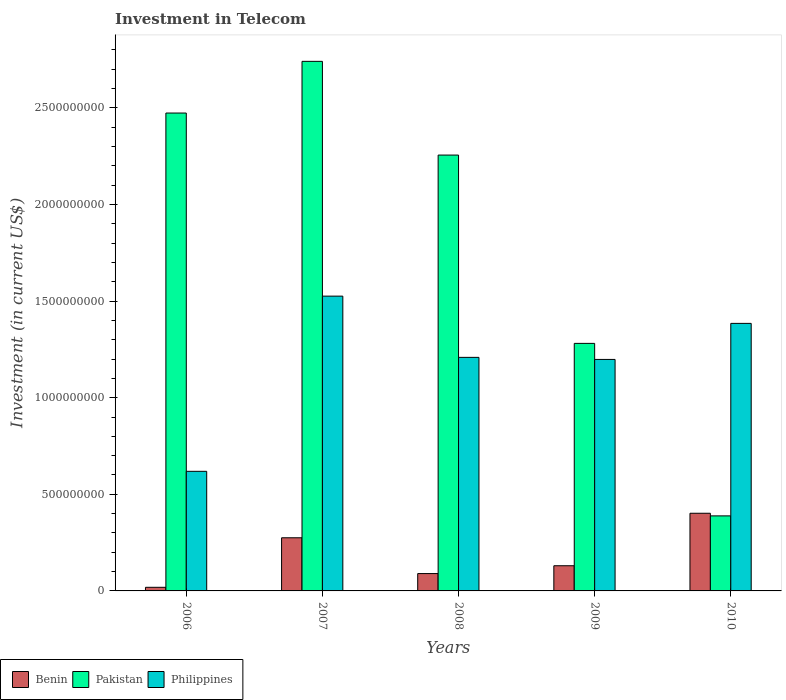How many different coloured bars are there?
Your answer should be compact. 3. Are the number of bars on each tick of the X-axis equal?
Provide a short and direct response. Yes. In how many cases, is the number of bars for a given year not equal to the number of legend labels?
Ensure brevity in your answer.  0. What is the amount invested in telecom in Pakistan in 2010?
Give a very brief answer. 3.88e+08. Across all years, what is the maximum amount invested in telecom in Pakistan?
Provide a succinct answer. 2.74e+09. Across all years, what is the minimum amount invested in telecom in Philippines?
Provide a short and direct response. 6.19e+08. In which year was the amount invested in telecom in Philippines maximum?
Your answer should be very brief. 2007. In which year was the amount invested in telecom in Pakistan minimum?
Provide a short and direct response. 2010. What is the total amount invested in telecom in Pakistan in the graph?
Provide a succinct answer. 9.14e+09. What is the difference between the amount invested in telecom in Pakistan in 2008 and that in 2009?
Make the answer very short. 9.74e+08. What is the difference between the amount invested in telecom in Philippines in 2009 and the amount invested in telecom in Pakistan in 2006?
Make the answer very short. -1.28e+09. What is the average amount invested in telecom in Philippines per year?
Give a very brief answer. 1.19e+09. In the year 2009, what is the difference between the amount invested in telecom in Pakistan and amount invested in telecom in Benin?
Your answer should be compact. 1.15e+09. What is the ratio of the amount invested in telecom in Benin in 2009 to that in 2010?
Make the answer very short. 0.32. What is the difference between the highest and the second highest amount invested in telecom in Pakistan?
Ensure brevity in your answer.  2.68e+08. What is the difference between the highest and the lowest amount invested in telecom in Philippines?
Offer a terse response. 9.07e+08. Is the sum of the amount invested in telecom in Pakistan in 2006 and 2007 greater than the maximum amount invested in telecom in Benin across all years?
Your response must be concise. Yes. What does the 1st bar from the left in 2010 represents?
Offer a terse response. Benin. What does the 1st bar from the right in 2009 represents?
Keep it short and to the point. Philippines. Is it the case that in every year, the sum of the amount invested in telecom in Benin and amount invested in telecom in Pakistan is greater than the amount invested in telecom in Philippines?
Your answer should be very brief. No. What is the difference between two consecutive major ticks on the Y-axis?
Your response must be concise. 5.00e+08. Are the values on the major ticks of Y-axis written in scientific E-notation?
Your answer should be compact. No. How are the legend labels stacked?
Provide a short and direct response. Horizontal. What is the title of the graph?
Your answer should be compact. Investment in Telecom. What is the label or title of the Y-axis?
Provide a succinct answer. Investment (in current US$). What is the Investment (in current US$) of Benin in 2006?
Keep it short and to the point. 1.87e+07. What is the Investment (in current US$) of Pakistan in 2006?
Offer a very short reply. 2.47e+09. What is the Investment (in current US$) of Philippines in 2006?
Give a very brief answer. 6.19e+08. What is the Investment (in current US$) in Benin in 2007?
Provide a succinct answer. 2.75e+08. What is the Investment (in current US$) in Pakistan in 2007?
Make the answer very short. 2.74e+09. What is the Investment (in current US$) of Philippines in 2007?
Provide a short and direct response. 1.53e+09. What is the Investment (in current US$) of Benin in 2008?
Your answer should be compact. 8.98e+07. What is the Investment (in current US$) in Pakistan in 2008?
Your response must be concise. 2.26e+09. What is the Investment (in current US$) in Philippines in 2008?
Ensure brevity in your answer.  1.21e+09. What is the Investment (in current US$) in Benin in 2009?
Your answer should be compact. 1.30e+08. What is the Investment (in current US$) of Pakistan in 2009?
Offer a terse response. 1.28e+09. What is the Investment (in current US$) in Philippines in 2009?
Provide a succinct answer. 1.20e+09. What is the Investment (in current US$) in Benin in 2010?
Your response must be concise. 4.02e+08. What is the Investment (in current US$) of Pakistan in 2010?
Give a very brief answer. 3.88e+08. What is the Investment (in current US$) in Philippines in 2010?
Your response must be concise. 1.38e+09. Across all years, what is the maximum Investment (in current US$) in Benin?
Offer a very short reply. 4.02e+08. Across all years, what is the maximum Investment (in current US$) in Pakistan?
Ensure brevity in your answer.  2.74e+09. Across all years, what is the maximum Investment (in current US$) in Philippines?
Your answer should be very brief. 1.53e+09. Across all years, what is the minimum Investment (in current US$) of Benin?
Give a very brief answer. 1.87e+07. Across all years, what is the minimum Investment (in current US$) in Pakistan?
Make the answer very short. 3.88e+08. Across all years, what is the minimum Investment (in current US$) of Philippines?
Your answer should be very brief. 6.19e+08. What is the total Investment (in current US$) in Benin in the graph?
Provide a short and direct response. 9.16e+08. What is the total Investment (in current US$) of Pakistan in the graph?
Ensure brevity in your answer.  9.14e+09. What is the total Investment (in current US$) in Philippines in the graph?
Offer a terse response. 5.94e+09. What is the difference between the Investment (in current US$) of Benin in 2006 and that in 2007?
Offer a very short reply. -2.56e+08. What is the difference between the Investment (in current US$) in Pakistan in 2006 and that in 2007?
Offer a terse response. -2.68e+08. What is the difference between the Investment (in current US$) in Philippines in 2006 and that in 2007?
Keep it short and to the point. -9.07e+08. What is the difference between the Investment (in current US$) of Benin in 2006 and that in 2008?
Ensure brevity in your answer.  -7.11e+07. What is the difference between the Investment (in current US$) of Pakistan in 2006 and that in 2008?
Provide a short and direct response. 2.18e+08. What is the difference between the Investment (in current US$) of Philippines in 2006 and that in 2008?
Your answer should be very brief. -5.90e+08. What is the difference between the Investment (in current US$) in Benin in 2006 and that in 2009?
Your response must be concise. -1.12e+08. What is the difference between the Investment (in current US$) of Pakistan in 2006 and that in 2009?
Offer a very short reply. 1.19e+09. What is the difference between the Investment (in current US$) of Philippines in 2006 and that in 2009?
Keep it short and to the point. -5.79e+08. What is the difference between the Investment (in current US$) of Benin in 2006 and that in 2010?
Your answer should be compact. -3.83e+08. What is the difference between the Investment (in current US$) in Pakistan in 2006 and that in 2010?
Your answer should be compact. 2.08e+09. What is the difference between the Investment (in current US$) of Philippines in 2006 and that in 2010?
Make the answer very short. -7.66e+08. What is the difference between the Investment (in current US$) in Benin in 2007 and that in 2008?
Give a very brief answer. 1.85e+08. What is the difference between the Investment (in current US$) in Pakistan in 2007 and that in 2008?
Keep it short and to the point. 4.85e+08. What is the difference between the Investment (in current US$) in Philippines in 2007 and that in 2008?
Your answer should be compact. 3.17e+08. What is the difference between the Investment (in current US$) of Benin in 2007 and that in 2009?
Provide a succinct answer. 1.45e+08. What is the difference between the Investment (in current US$) in Pakistan in 2007 and that in 2009?
Provide a succinct answer. 1.46e+09. What is the difference between the Investment (in current US$) of Philippines in 2007 and that in 2009?
Your answer should be compact. 3.28e+08. What is the difference between the Investment (in current US$) in Benin in 2007 and that in 2010?
Provide a short and direct response. -1.27e+08. What is the difference between the Investment (in current US$) of Pakistan in 2007 and that in 2010?
Your response must be concise. 2.35e+09. What is the difference between the Investment (in current US$) in Philippines in 2007 and that in 2010?
Provide a succinct answer. 1.41e+08. What is the difference between the Investment (in current US$) of Benin in 2008 and that in 2009?
Keep it short and to the point. -4.05e+07. What is the difference between the Investment (in current US$) in Pakistan in 2008 and that in 2009?
Offer a very short reply. 9.74e+08. What is the difference between the Investment (in current US$) of Philippines in 2008 and that in 2009?
Offer a very short reply. 1.06e+07. What is the difference between the Investment (in current US$) in Benin in 2008 and that in 2010?
Offer a terse response. -3.12e+08. What is the difference between the Investment (in current US$) of Pakistan in 2008 and that in 2010?
Make the answer very short. 1.87e+09. What is the difference between the Investment (in current US$) of Philippines in 2008 and that in 2010?
Offer a terse response. -1.76e+08. What is the difference between the Investment (in current US$) of Benin in 2009 and that in 2010?
Your answer should be compact. -2.72e+08. What is the difference between the Investment (in current US$) of Pakistan in 2009 and that in 2010?
Offer a very short reply. 8.93e+08. What is the difference between the Investment (in current US$) of Philippines in 2009 and that in 2010?
Provide a short and direct response. -1.86e+08. What is the difference between the Investment (in current US$) of Benin in 2006 and the Investment (in current US$) of Pakistan in 2007?
Ensure brevity in your answer.  -2.72e+09. What is the difference between the Investment (in current US$) in Benin in 2006 and the Investment (in current US$) in Philippines in 2007?
Your response must be concise. -1.51e+09. What is the difference between the Investment (in current US$) of Pakistan in 2006 and the Investment (in current US$) of Philippines in 2007?
Make the answer very short. 9.48e+08. What is the difference between the Investment (in current US$) in Benin in 2006 and the Investment (in current US$) in Pakistan in 2008?
Provide a short and direct response. -2.24e+09. What is the difference between the Investment (in current US$) of Benin in 2006 and the Investment (in current US$) of Philippines in 2008?
Make the answer very short. -1.19e+09. What is the difference between the Investment (in current US$) of Pakistan in 2006 and the Investment (in current US$) of Philippines in 2008?
Keep it short and to the point. 1.26e+09. What is the difference between the Investment (in current US$) in Benin in 2006 and the Investment (in current US$) in Pakistan in 2009?
Your response must be concise. -1.26e+09. What is the difference between the Investment (in current US$) of Benin in 2006 and the Investment (in current US$) of Philippines in 2009?
Keep it short and to the point. -1.18e+09. What is the difference between the Investment (in current US$) in Pakistan in 2006 and the Investment (in current US$) in Philippines in 2009?
Give a very brief answer. 1.28e+09. What is the difference between the Investment (in current US$) of Benin in 2006 and the Investment (in current US$) of Pakistan in 2010?
Your answer should be compact. -3.70e+08. What is the difference between the Investment (in current US$) in Benin in 2006 and the Investment (in current US$) in Philippines in 2010?
Make the answer very short. -1.37e+09. What is the difference between the Investment (in current US$) of Pakistan in 2006 and the Investment (in current US$) of Philippines in 2010?
Your response must be concise. 1.09e+09. What is the difference between the Investment (in current US$) in Benin in 2007 and the Investment (in current US$) in Pakistan in 2008?
Your answer should be very brief. -1.98e+09. What is the difference between the Investment (in current US$) in Benin in 2007 and the Investment (in current US$) in Philippines in 2008?
Ensure brevity in your answer.  -9.34e+08. What is the difference between the Investment (in current US$) in Pakistan in 2007 and the Investment (in current US$) in Philippines in 2008?
Offer a very short reply. 1.53e+09. What is the difference between the Investment (in current US$) of Benin in 2007 and the Investment (in current US$) of Pakistan in 2009?
Your response must be concise. -1.01e+09. What is the difference between the Investment (in current US$) of Benin in 2007 and the Investment (in current US$) of Philippines in 2009?
Keep it short and to the point. -9.23e+08. What is the difference between the Investment (in current US$) in Pakistan in 2007 and the Investment (in current US$) in Philippines in 2009?
Offer a terse response. 1.54e+09. What is the difference between the Investment (in current US$) in Benin in 2007 and the Investment (in current US$) in Pakistan in 2010?
Offer a very short reply. -1.13e+08. What is the difference between the Investment (in current US$) of Benin in 2007 and the Investment (in current US$) of Philippines in 2010?
Offer a terse response. -1.11e+09. What is the difference between the Investment (in current US$) of Pakistan in 2007 and the Investment (in current US$) of Philippines in 2010?
Provide a short and direct response. 1.36e+09. What is the difference between the Investment (in current US$) of Benin in 2008 and the Investment (in current US$) of Pakistan in 2009?
Ensure brevity in your answer.  -1.19e+09. What is the difference between the Investment (in current US$) in Benin in 2008 and the Investment (in current US$) in Philippines in 2009?
Your answer should be compact. -1.11e+09. What is the difference between the Investment (in current US$) of Pakistan in 2008 and the Investment (in current US$) of Philippines in 2009?
Offer a very short reply. 1.06e+09. What is the difference between the Investment (in current US$) in Benin in 2008 and the Investment (in current US$) in Pakistan in 2010?
Offer a very short reply. -2.98e+08. What is the difference between the Investment (in current US$) of Benin in 2008 and the Investment (in current US$) of Philippines in 2010?
Offer a terse response. -1.29e+09. What is the difference between the Investment (in current US$) in Pakistan in 2008 and the Investment (in current US$) in Philippines in 2010?
Make the answer very short. 8.71e+08. What is the difference between the Investment (in current US$) in Benin in 2009 and the Investment (in current US$) in Pakistan in 2010?
Make the answer very short. -2.58e+08. What is the difference between the Investment (in current US$) in Benin in 2009 and the Investment (in current US$) in Philippines in 2010?
Offer a very short reply. -1.25e+09. What is the difference between the Investment (in current US$) in Pakistan in 2009 and the Investment (in current US$) in Philippines in 2010?
Offer a terse response. -1.04e+08. What is the average Investment (in current US$) in Benin per year?
Offer a terse response. 1.83e+08. What is the average Investment (in current US$) in Pakistan per year?
Your answer should be very brief. 1.83e+09. What is the average Investment (in current US$) of Philippines per year?
Your answer should be compact. 1.19e+09. In the year 2006, what is the difference between the Investment (in current US$) in Benin and Investment (in current US$) in Pakistan?
Your response must be concise. -2.45e+09. In the year 2006, what is the difference between the Investment (in current US$) in Benin and Investment (in current US$) in Philippines?
Provide a short and direct response. -6.00e+08. In the year 2006, what is the difference between the Investment (in current US$) of Pakistan and Investment (in current US$) of Philippines?
Your answer should be very brief. 1.85e+09. In the year 2007, what is the difference between the Investment (in current US$) in Benin and Investment (in current US$) in Pakistan?
Ensure brevity in your answer.  -2.47e+09. In the year 2007, what is the difference between the Investment (in current US$) in Benin and Investment (in current US$) in Philippines?
Offer a very short reply. -1.25e+09. In the year 2007, what is the difference between the Investment (in current US$) of Pakistan and Investment (in current US$) of Philippines?
Provide a short and direct response. 1.22e+09. In the year 2008, what is the difference between the Investment (in current US$) in Benin and Investment (in current US$) in Pakistan?
Give a very brief answer. -2.17e+09. In the year 2008, what is the difference between the Investment (in current US$) in Benin and Investment (in current US$) in Philippines?
Make the answer very short. -1.12e+09. In the year 2008, what is the difference between the Investment (in current US$) in Pakistan and Investment (in current US$) in Philippines?
Make the answer very short. 1.05e+09. In the year 2009, what is the difference between the Investment (in current US$) of Benin and Investment (in current US$) of Pakistan?
Make the answer very short. -1.15e+09. In the year 2009, what is the difference between the Investment (in current US$) of Benin and Investment (in current US$) of Philippines?
Your answer should be very brief. -1.07e+09. In the year 2009, what is the difference between the Investment (in current US$) of Pakistan and Investment (in current US$) of Philippines?
Ensure brevity in your answer.  8.30e+07. In the year 2010, what is the difference between the Investment (in current US$) of Benin and Investment (in current US$) of Pakistan?
Ensure brevity in your answer.  1.36e+07. In the year 2010, what is the difference between the Investment (in current US$) of Benin and Investment (in current US$) of Philippines?
Keep it short and to the point. -9.83e+08. In the year 2010, what is the difference between the Investment (in current US$) of Pakistan and Investment (in current US$) of Philippines?
Keep it short and to the point. -9.96e+08. What is the ratio of the Investment (in current US$) of Benin in 2006 to that in 2007?
Provide a short and direct response. 0.07. What is the ratio of the Investment (in current US$) in Pakistan in 2006 to that in 2007?
Your answer should be very brief. 0.9. What is the ratio of the Investment (in current US$) of Philippines in 2006 to that in 2007?
Provide a short and direct response. 0.41. What is the ratio of the Investment (in current US$) of Benin in 2006 to that in 2008?
Keep it short and to the point. 0.21. What is the ratio of the Investment (in current US$) of Pakistan in 2006 to that in 2008?
Make the answer very short. 1.1. What is the ratio of the Investment (in current US$) of Philippines in 2006 to that in 2008?
Keep it short and to the point. 0.51. What is the ratio of the Investment (in current US$) of Benin in 2006 to that in 2009?
Ensure brevity in your answer.  0.14. What is the ratio of the Investment (in current US$) of Pakistan in 2006 to that in 2009?
Offer a terse response. 1.93. What is the ratio of the Investment (in current US$) of Philippines in 2006 to that in 2009?
Ensure brevity in your answer.  0.52. What is the ratio of the Investment (in current US$) of Benin in 2006 to that in 2010?
Your answer should be compact. 0.05. What is the ratio of the Investment (in current US$) of Pakistan in 2006 to that in 2010?
Offer a terse response. 6.37. What is the ratio of the Investment (in current US$) of Philippines in 2006 to that in 2010?
Give a very brief answer. 0.45. What is the ratio of the Investment (in current US$) of Benin in 2007 to that in 2008?
Provide a succinct answer. 3.06. What is the ratio of the Investment (in current US$) in Pakistan in 2007 to that in 2008?
Your response must be concise. 1.22. What is the ratio of the Investment (in current US$) of Philippines in 2007 to that in 2008?
Your answer should be compact. 1.26. What is the ratio of the Investment (in current US$) in Benin in 2007 to that in 2009?
Keep it short and to the point. 2.11. What is the ratio of the Investment (in current US$) in Pakistan in 2007 to that in 2009?
Ensure brevity in your answer.  2.14. What is the ratio of the Investment (in current US$) in Philippines in 2007 to that in 2009?
Your response must be concise. 1.27. What is the ratio of the Investment (in current US$) in Benin in 2007 to that in 2010?
Your response must be concise. 0.68. What is the ratio of the Investment (in current US$) of Pakistan in 2007 to that in 2010?
Give a very brief answer. 7.06. What is the ratio of the Investment (in current US$) of Philippines in 2007 to that in 2010?
Your answer should be very brief. 1.1. What is the ratio of the Investment (in current US$) of Benin in 2008 to that in 2009?
Your answer should be compact. 0.69. What is the ratio of the Investment (in current US$) of Pakistan in 2008 to that in 2009?
Offer a terse response. 1.76. What is the ratio of the Investment (in current US$) in Philippines in 2008 to that in 2009?
Your answer should be compact. 1.01. What is the ratio of the Investment (in current US$) of Benin in 2008 to that in 2010?
Offer a terse response. 0.22. What is the ratio of the Investment (in current US$) in Pakistan in 2008 to that in 2010?
Ensure brevity in your answer.  5.81. What is the ratio of the Investment (in current US$) in Philippines in 2008 to that in 2010?
Keep it short and to the point. 0.87. What is the ratio of the Investment (in current US$) of Benin in 2009 to that in 2010?
Offer a terse response. 0.32. What is the ratio of the Investment (in current US$) of Pakistan in 2009 to that in 2010?
Your response must be concise. 3.3. What is the ratio of the Investment (in current US$) of Philippines in 2009 to that in 2010?
Your answer should be compact. 0.87. What is the difference between the highest and the second highest Investment (in current US$) of Benin?
Your response must be concise. 1.27e+08. What is the difference between the highest and the second highest Investment (in current US$) in Pakistan?
Keep it short and to the point. 2.68e+08. What is the difference between the highest and the second highest Investment (in current US$) in Philippines?
Provide a short and direct response. 1.41e+08. What is the difference between the highest and the lowest Investment (in current US$) of Benin?
Ensure brevity in your answer.  3.83e+08. What is the difference between the highest and the lowest Investment (in current US$) in Pakistan?
Keep it short and to the point. 2.35e+09. What is the difference between the highest and the lowest Investment (in current US$) of Philippines?
Your answer should be very brief. 9.07e+08. 